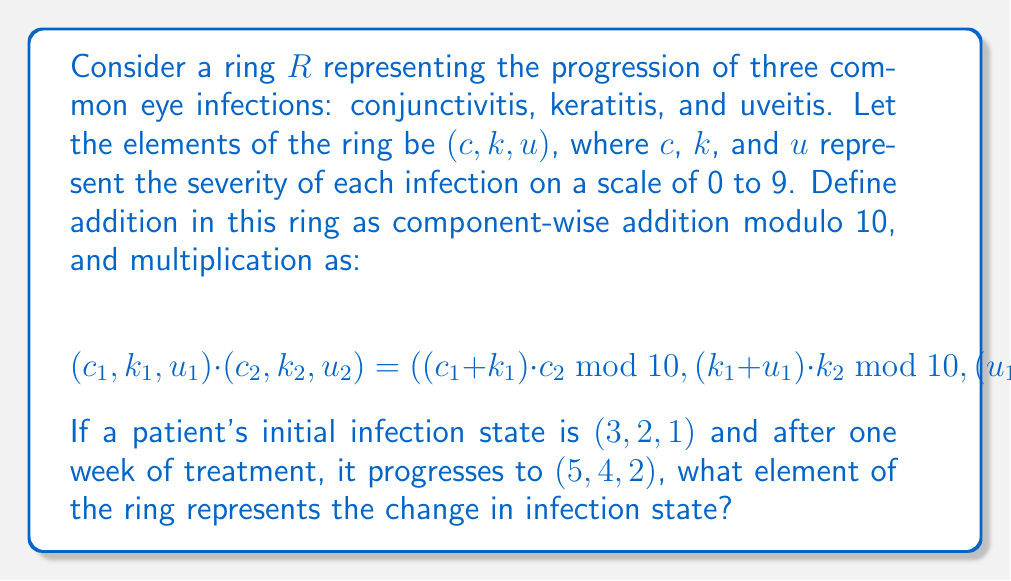Could you help me with this problem? To solve this problem, we need to find an element $(x, y, z)$ in the ring such that:

$$(3, 2, 1) + (x, y, z) = (5, 4, 2)$$

Let's solve this step-by-step:

1) For the first component:
   $(3 + x) \bmod 10 = 5$
   $x = 2$

2) For the second component:
   $(2 + y) \bmod 10 = 4$
   $y = 2$

3) For the third component:
   $(1 + z) \bmod 10 = 2$
   $z = 1$

Therefore, the element representing the change in infection state is $(2, 2, 1)$.

To verify, let's add $(3, 2, 1)$ and $(2, 2, 1)$ using the defined addition operation:

$$(3, 2, 1) + (2, 2, 1) = ((3+2) \bmod 10, (2+2) \bmod 10, (1+1) \bmod 10) = (5, 4, 2)$$

This confirms our solution.
Answer: $(2, 2, 1)$ 